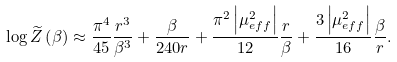Convert formula to latex. <formula><loc_0><loc_0><loc_500><loc_500>\log \widetilde { Z } \left ( \beta \right ) \approx \frac { \pi ^ { 4 } } { 4 5 } \frac { r ^ { 3 } } { \beta ^ { 3 } } + \frac { \beta } { 2 4 0 r } + \frac { \pi ^ { 2 } \left | \mu _ { e f f } ^ { 2 } \right | } { 1 2 } \frac { r } { \beta } + \frac { 3 \left | \mu _ { e f f } ^ { 2 } \right | } { 1 6 } \frac { \beta } { r } .</formula> 